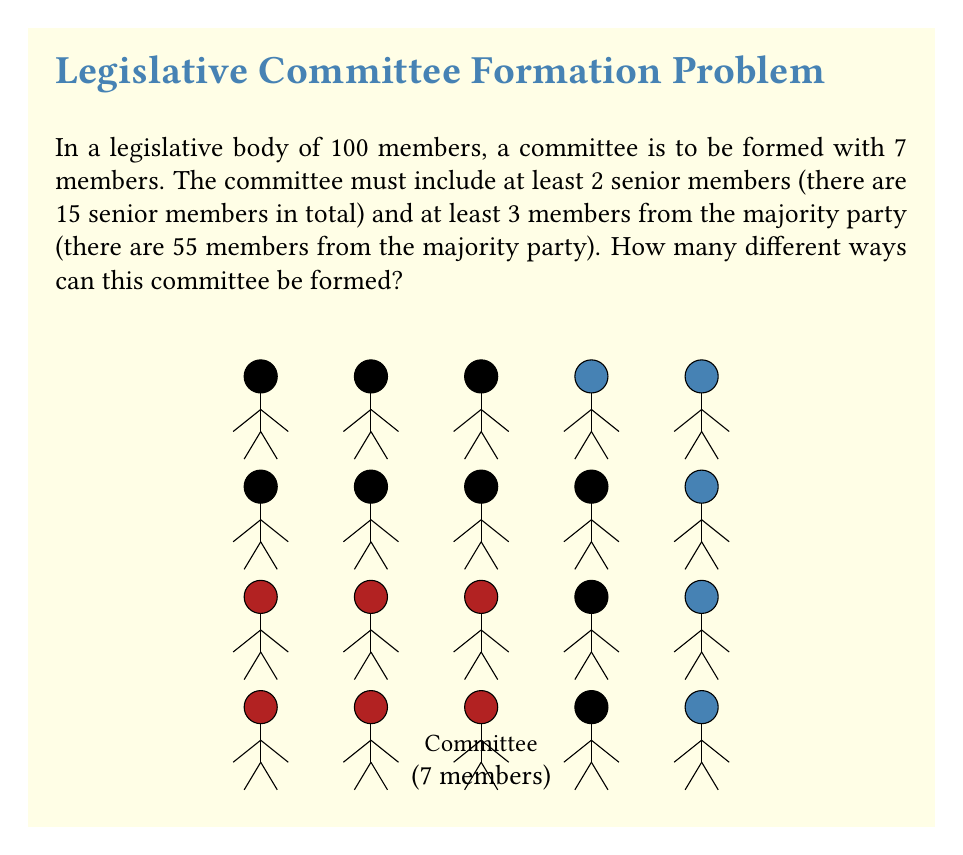Could you help me with this problem? Let's approach this step-by-step:

1) First, we need to consider the constraints:
   - Total committee size: 7
   - At least 2 senior members
   - At least 3 majority party members

2) We can break this down into cases based on the number of senior members:

   Case 1: 2 senior members
   Case 2: 3 senior members
   Case 3: 4 senior members
   Case 4: 5 senior members
   Case 5: 6 senior members
   Case 6: 7 senior members

3) For each case, we'll calculate the number of ways to select the remaining members:

   Case 1: 2 senior members
   - Choose 2 from 15 senior members: $\binom{15}{2}$
   - Need at least 3 majority members from the remaining 5 spots
   - This can be 3, 4, or 5 majority members
   - Ways: $\binom{55}{3}\binom{45}{2} + \binom{55}{4}\binom{45}{1} + \binom{55}{5}$

   Case 2: 3 senior members
   - Choose 3 from 15 senior members: $\binom{15}{3}$
   - Need at least 3 majority members from the remaining 4 spots
   - This can be 3 or 4 majority members
   - Ways: $\binom{55}{3}\binom{45}{1} + \binom{55}{4}$

   Case 3: 4 senior members
   - Choose 4 from 15 senior members: $\binom{15}{4}$
   - Need 3 majority members from the remaining 3 spots
   - Ways: $\binom{55}{3}$

   Cases 4, 5, and 6: Not possible as we need at least 3 majority members

4) The total number of ways is the sum of all these cases:

   $$\binom{15}{2}(\binom{55}{3}\binom{45}{2} + \binom{55}{4}\binom{45}{1} + \binom{55}{5}) +
     \binom{15}{3}(\binom{55}{3}\binom{45}{1} + \binom{55}{4}) +
     \binom{15}{4}\binom{55}{3}$$

5) Calculating this:
   $105(26235 + 341055 + 3478761) + 455(341055 + 3478761) + 1365(26235)$
   $= 105(3846051) + 455(3819816) + 35810775$
   $= 403835355 + 1738016280 + 35810775$
   $= 2177662410$

Therefore, there are 2,177,662,410 different ways to form the committee.
Answer: 2,177,662,410 